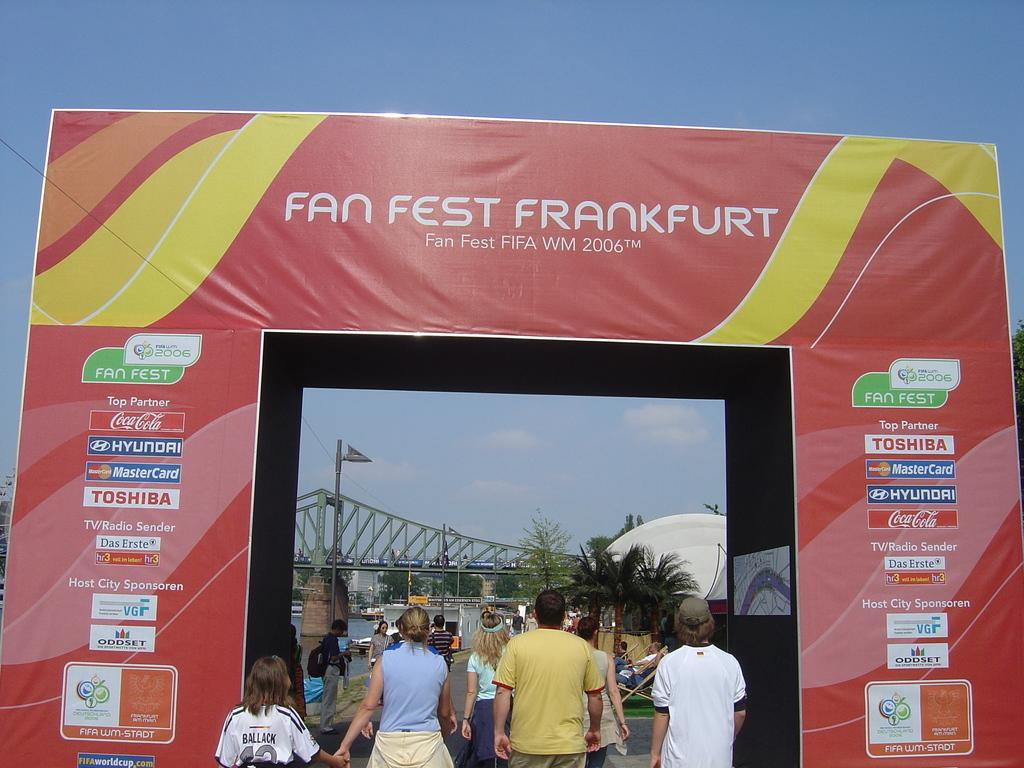What is the main structure visible in the image? There is a hoarding in the image. What are the people near the hoarding doing? The people are entering through the hoarding. What type of infrastructure is present in the image? There is a bridge in the image. What is visible under the bridge? There is water under the bridge. What type of street is visible on top of the bridge in the image? There is no street visible on top of the bridge in the image; it is a bridge over water. How does the image promote peace? The image does not specifically promote peace; it simply shows a hoarding, people entering through it, a bridge, and water under the bridge. 